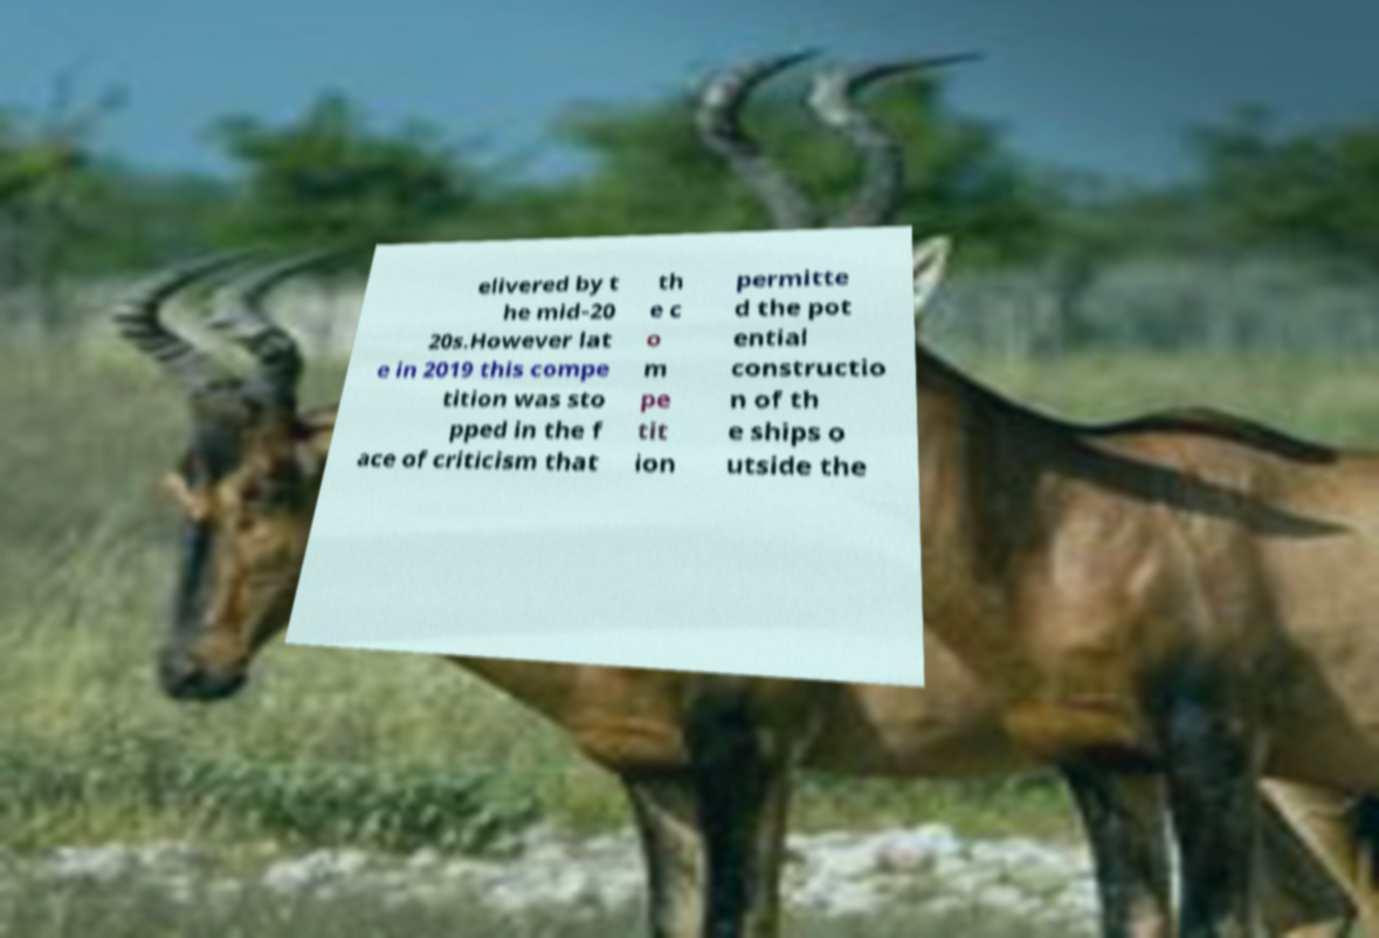There's text embedded in this image that I need extracted. Can you transcribe it verbatim? elivered by t he mid-20 20s.However lat e in 2019 this compe tition was sto pped in the f ace of criticism that th e c o m pe tit ion permitte d the pot ential constructio n of th e ships o utside the 